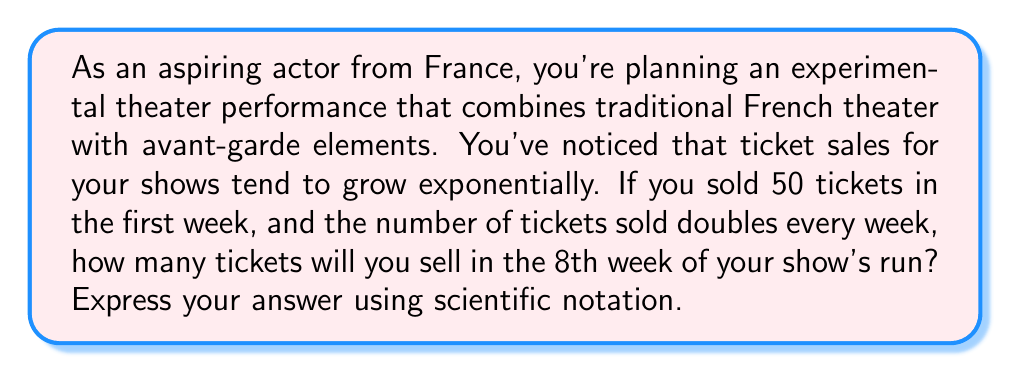Solve this math problem. Let's approach this step-by-step using an exponential function:

1) The general form of an exponential function is:
   $$ y = a \cdot b^x $$
   where $a$ is the initial value, $b$ is the growth factor, and $x$ is the number of time periods.

2) In this case:
   - $a = 50$ (initial ticket sales)
   - $b = 2$ (doubles every week)
   - $x = 7$ (we want the 8th week, which is 7 periods of doubling after the initial week)

3) Plugging these values into our function:
   $$ y = 50 \cdot 2^7 $$

4) Let's calculate this:
   $$ y = 50 \cdot 128 = 6400 $$

5) To express this in scientific notation, we move the decimal point 3 places to the left:
   $$ 6400 = 6.4 \times 10^3 $$

Thus, in the 8th week, you will sell 6400 tickets, or $6.4 \times 10^3$ in scientific notation.
Answer: $6.4 \times 10^3$ tickets 